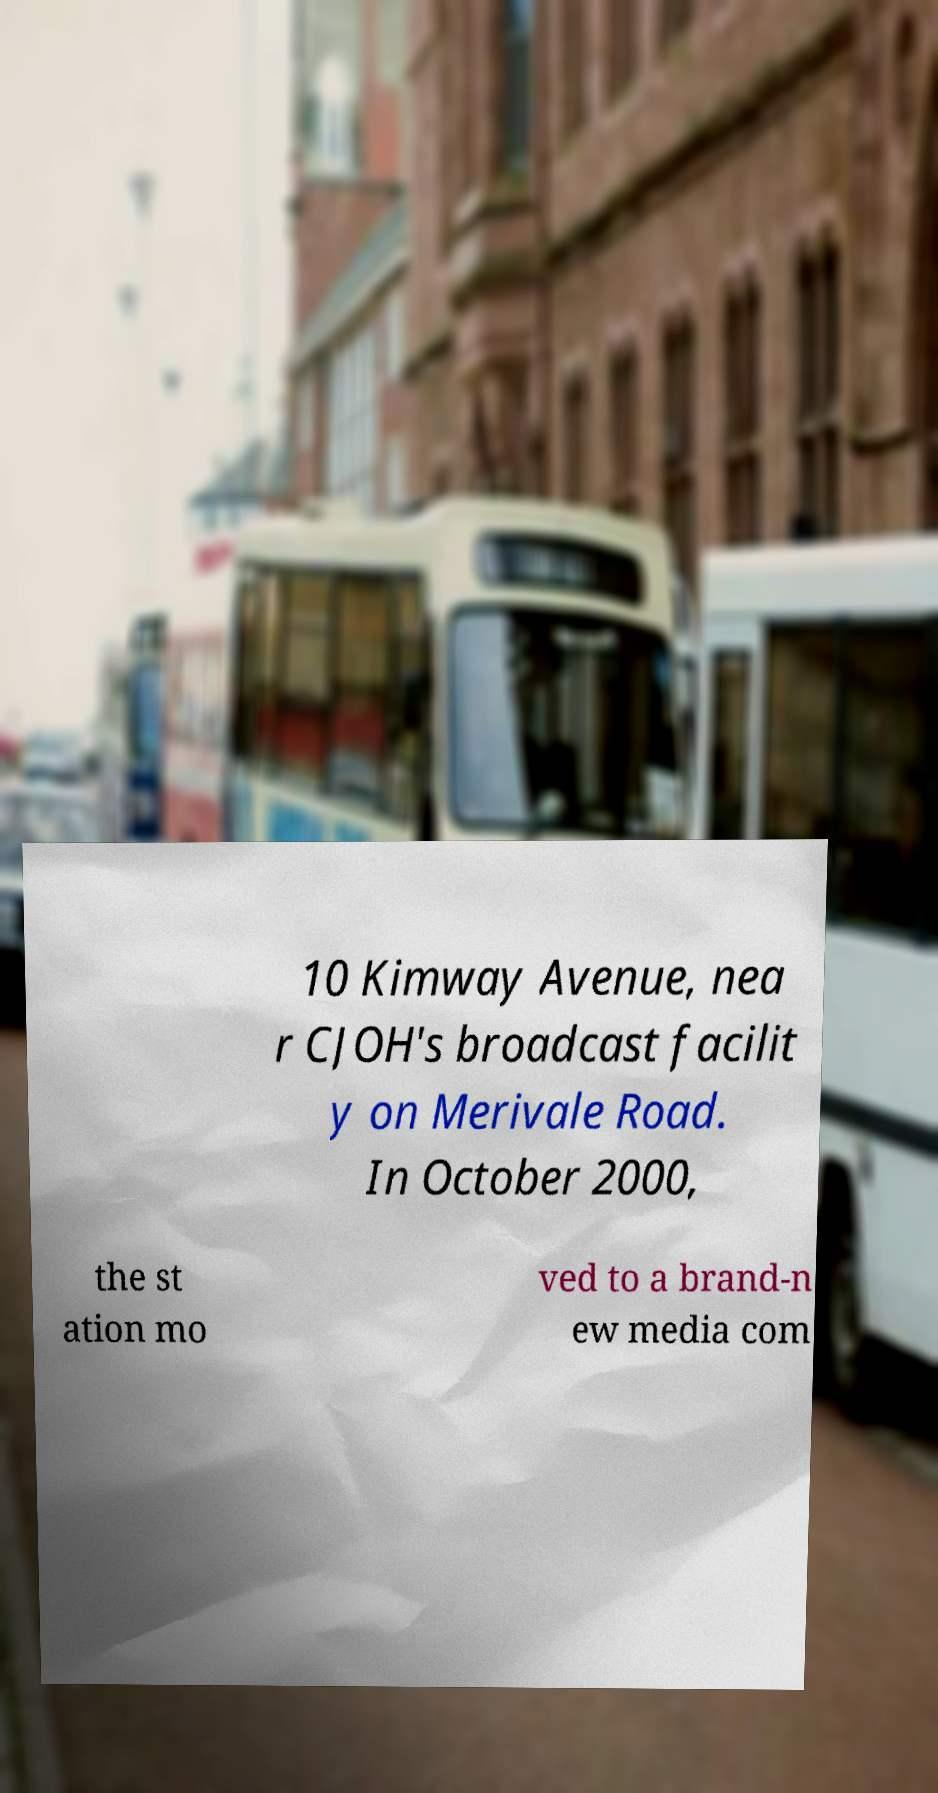I need the written content from this picture converted into text. Can you do that? 10 Kimway Avenue, nea r CJOH's broadcast facilit y on Merivale Road. In October 2000, the st ation mo ved to a brand-n ew media com 